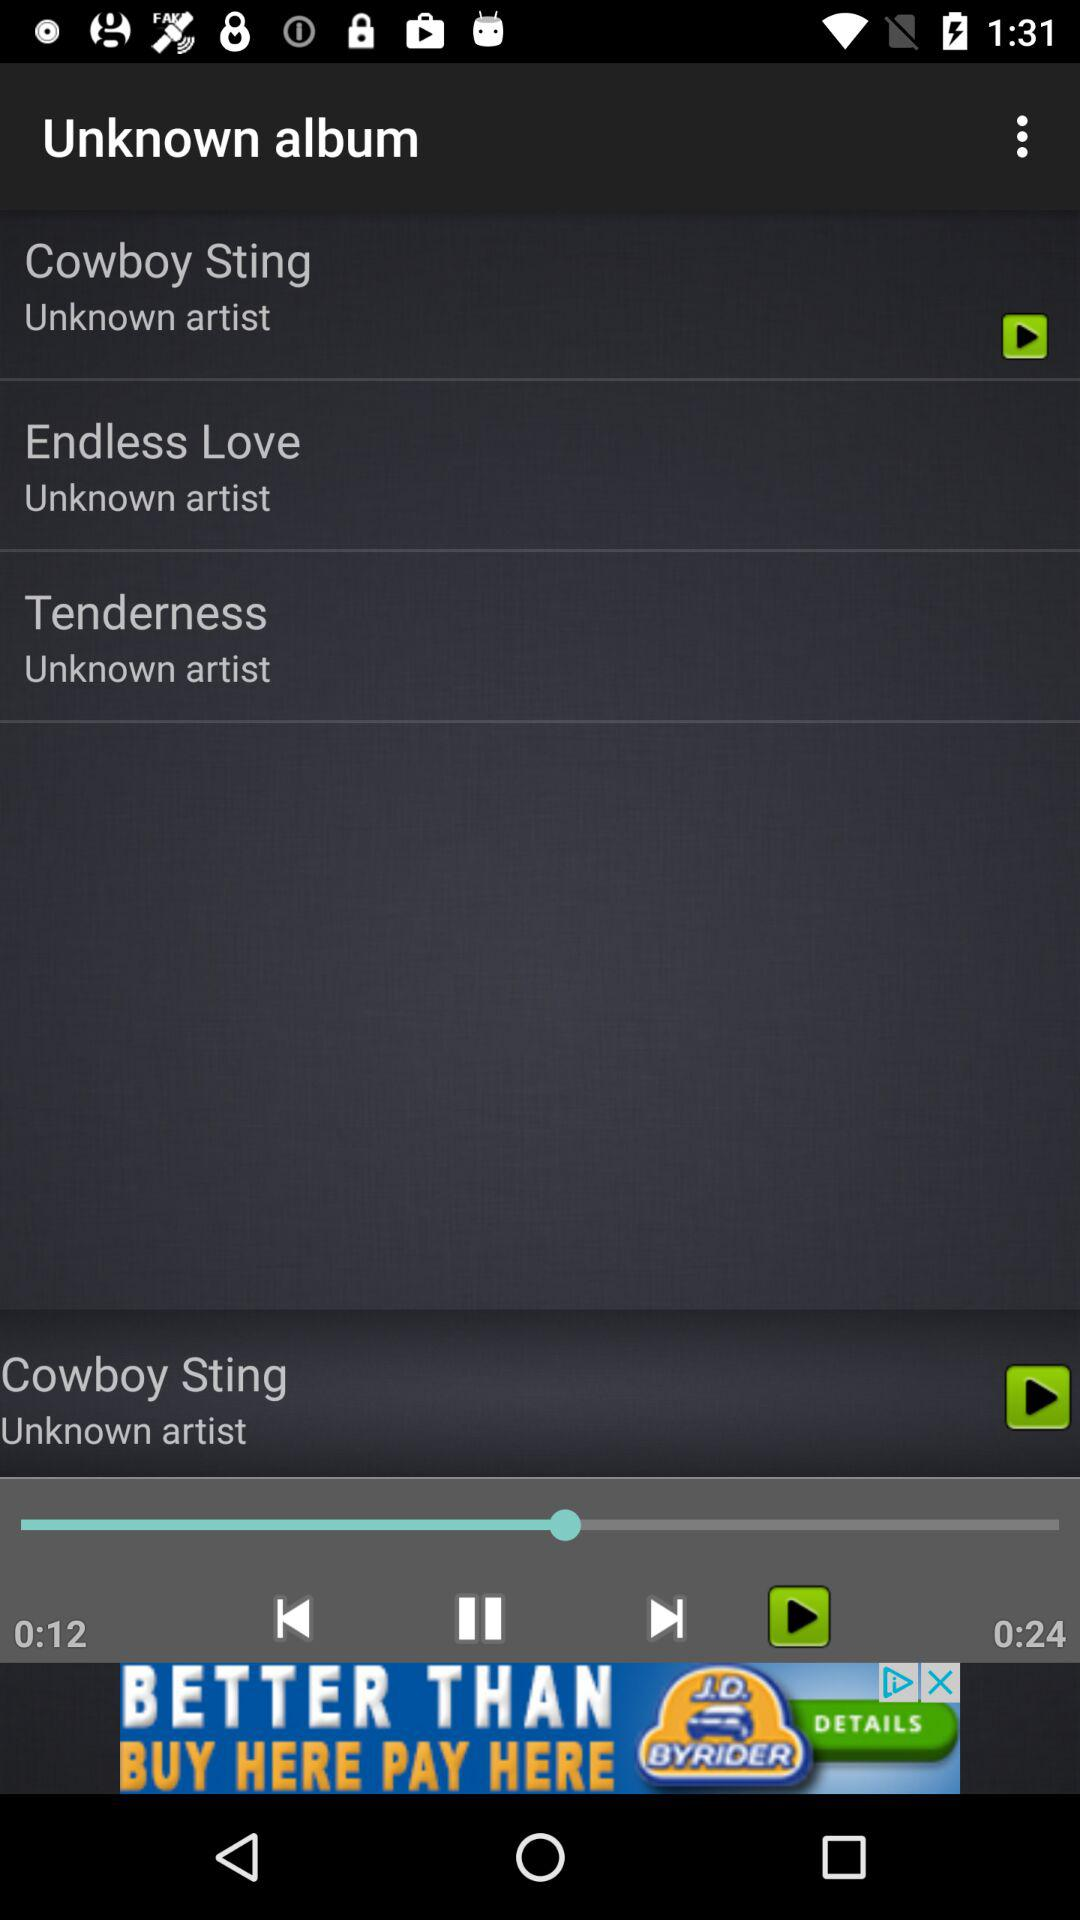What is the duration of "Tenderness"?
When the provided information is insufficient, respond with <no answer>. <no answer> 